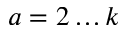<formula> <loc_0><loc_0><loc_500><loc_500>a = 2 \dots k</formula> 